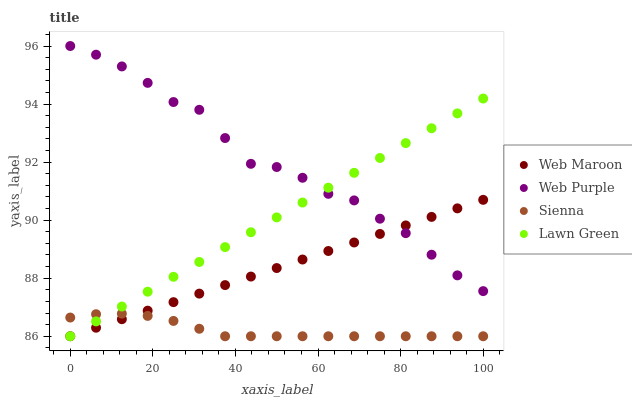Does Sienna have the minimum area under the curve?
Answer yes or no. Yes. Does Web Purple have the maximum area under the curve?
Answer yes or no. Yes. Does Lawn Green have the minimum area under the curve?
Answer yes or no. No. Does Lawn Green have the maximum area under the curve?
Answer yes or no. No. Is Lawn Green the smoothest?
Answer yes or no. Yes. Is Web Purple the roughest?
Answer yes or no. Yes. Is Web Purple the smoothest?
Answer yes or no. No. Is Lawn Green the roughest?
Answer yes or no. No. Does Sienna have the lowest value?
Answer yes or no. Yes. Does Web Purple have the lowest value?
Answer yes or no. No. Does Web Purple have the highest value?
Answer yes or no. Yes. Does Lawn Green have the highest value?
Answer yes or no. No. Is Sienna less than Web Purple?
Answer yes or no. Yes. Is Web Purple greater than Sienna?
Answer yes or no. Yes. Does Web Maroon intersect Web Purple?
Answer yes or no. Yes. Is Web Maroon less than Web Purple?
Answer yes or no. No. Is Web Maroon greater than Web Purple?
Answer yes or no. No. Does Sienna intersect Web Purple?
Answer yes or no. No. 